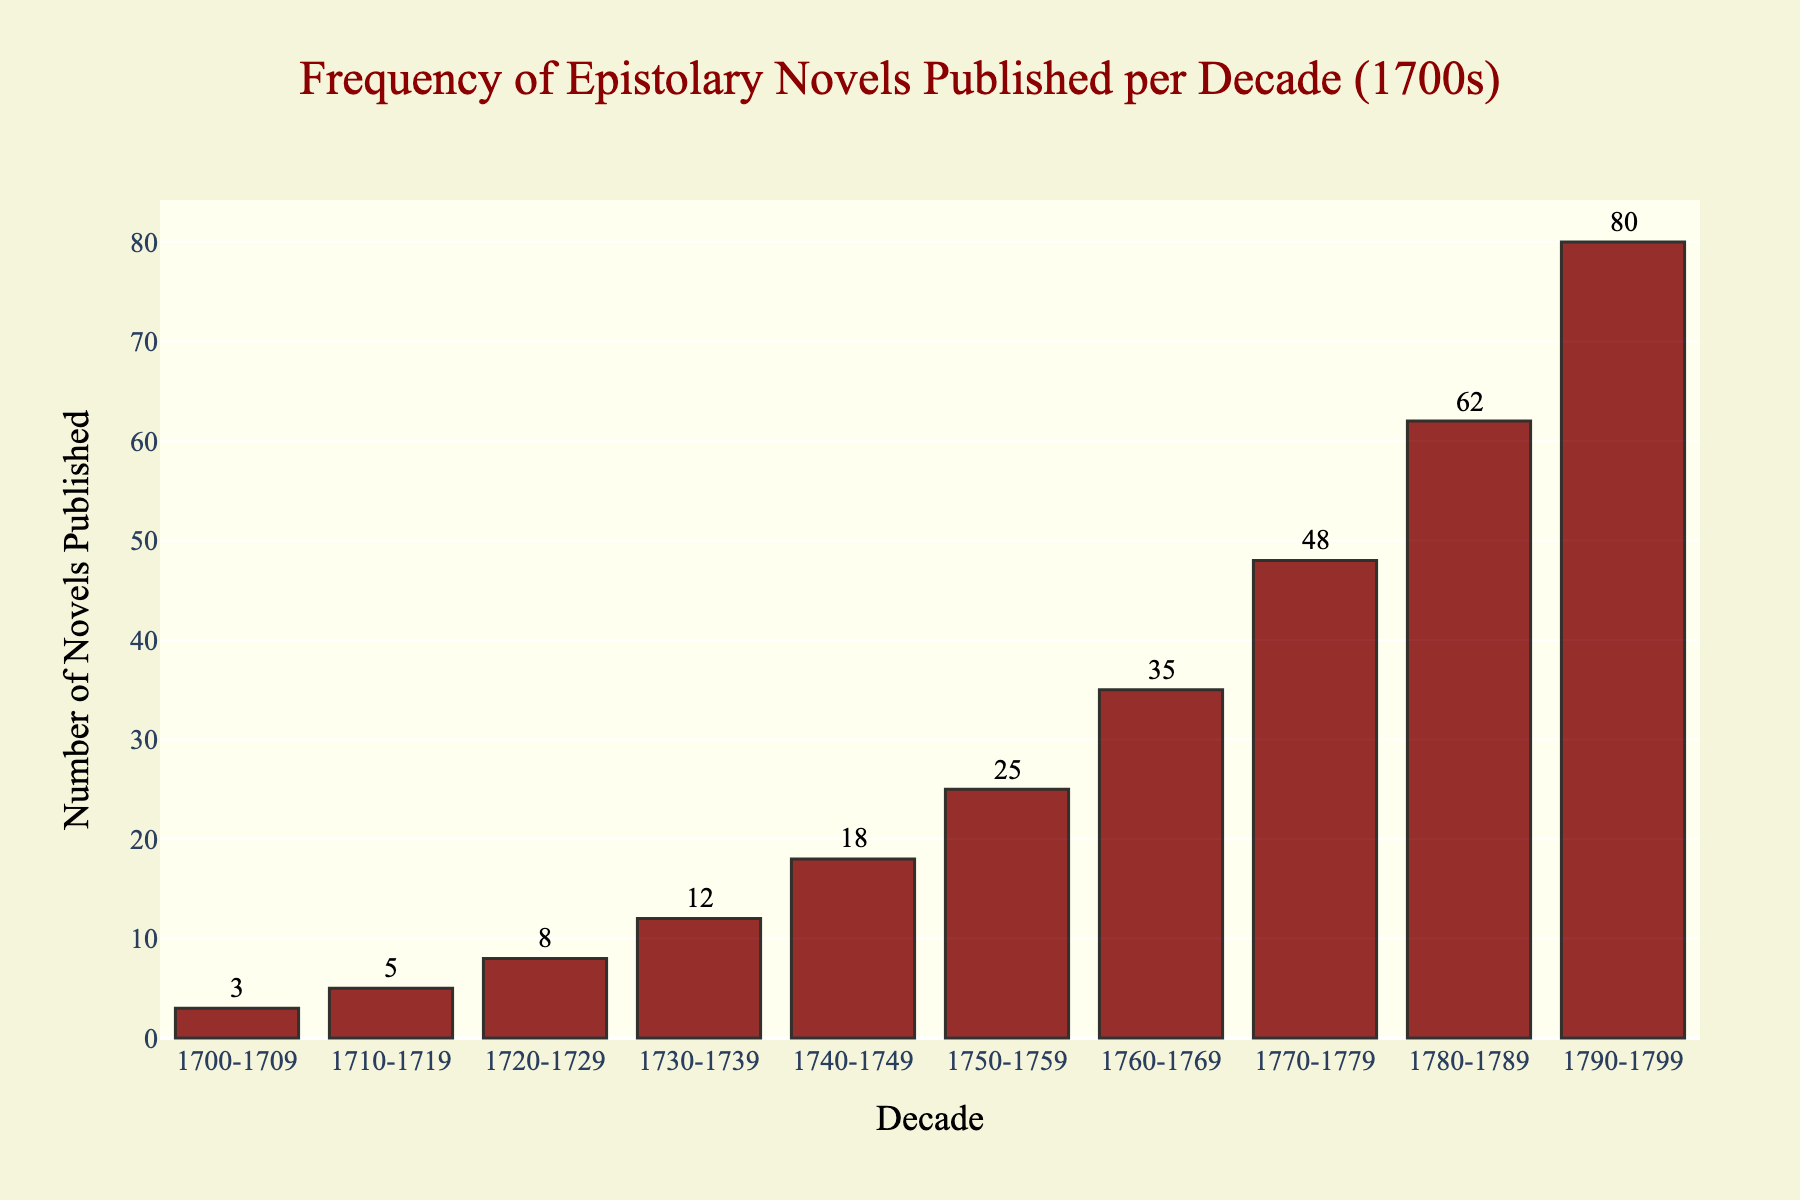What is the total number of epistolary novels published in the first half of the 18th century (1700-1749)? To determine the total number of novels published from 1700 to 1749, sum the quantities from the decades 1700-1709, 1710-1719, 1720-1729, 1730-1739, and 1740-1749: 3 + 5 + 8 + 12 + 18 = 46
Answer: 46 In which decade was the highest frequency of epistolary novels published? Identify the tallest bar or highest value on the y-axis, which represents the number of novels published. The highest bar corresponds to the decade 1790-1799 with 80 novels.
Answer: 1790-1799 How many more novels were published in the 1780s compared to the 1730s? Subtract the number of novels published in the 1730s from those in the 1780s: 62 (1780-1789) - 12 (1730-1739) = 50
Answer: 50 What is the average number of epistolary novels published per decade throughout the entire 1700s? Sum up all the published novels from each decade: 3 + 5 + 8 + 12 + 18 + 25 + 35 + 48 + 62 + 80 = 296. Then, divide the total by the number of decades (296/10): 296/10 = 29.6
Answer: 29.6 Which decade saw the greatest increase in the number of epistolary novels published compared to the previous decade? Calculate the differences between each consecutive decade's publications: 
1710-1719: 5 - 3 = 2, 
1720-1729: 8 - 5 = 3, 
1730-1739: 12 - 8 = 4, 
1740-1749: 18 - 12 = 6, 
1750-1759: 25 - 18 = 7, 
1760-1769: 35 - 25 = 10, 
1770-1779: 48 - 35 = 13, 
1780-1789: 62 - 48 = 14, 
1790-1799: 80 - 62 = 18. 
The greatest increase is from 1780-1789 to 1790-1799, an increase of 18.
Answer: 1790-1799 What is the ratio of novels published in the 1700s to the 1760s? Find the number of novels published in the 1700s (3) and in the 1760s (35) then calculate the ratio: 3 / 35 = 0.0857. Simplified as 1:11.67
Answer: 1:11.67 By what percentage did the number of novels published increase from the 1750s to the 1760s? First, find the difference: 35 - 25 = 10. Then, calculate the percentage increase: (10 / 25) * 100 = 40%
Answer: 40% What is the sum of novels published in the decades of the 1780s and the 1790s? Add the number of novels from 1780-1789 and 1790-1799: 62 + 80 = 142
Answer: 142 